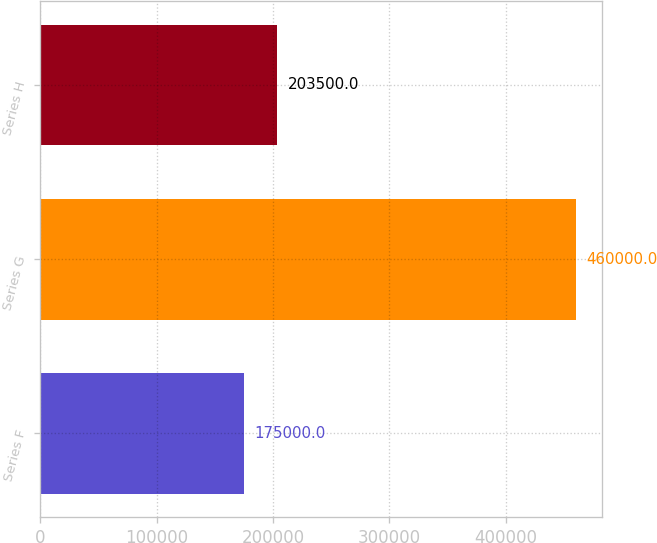Convert chart to OTSL. <chart><loc_0><loc_0><loc_500><loc_500><bar_chart><fcel>Series F<fcel>Series G<fcel>Series H<nl><fcel>175000<fcel>460000<fcel>203500<nl></chart> 